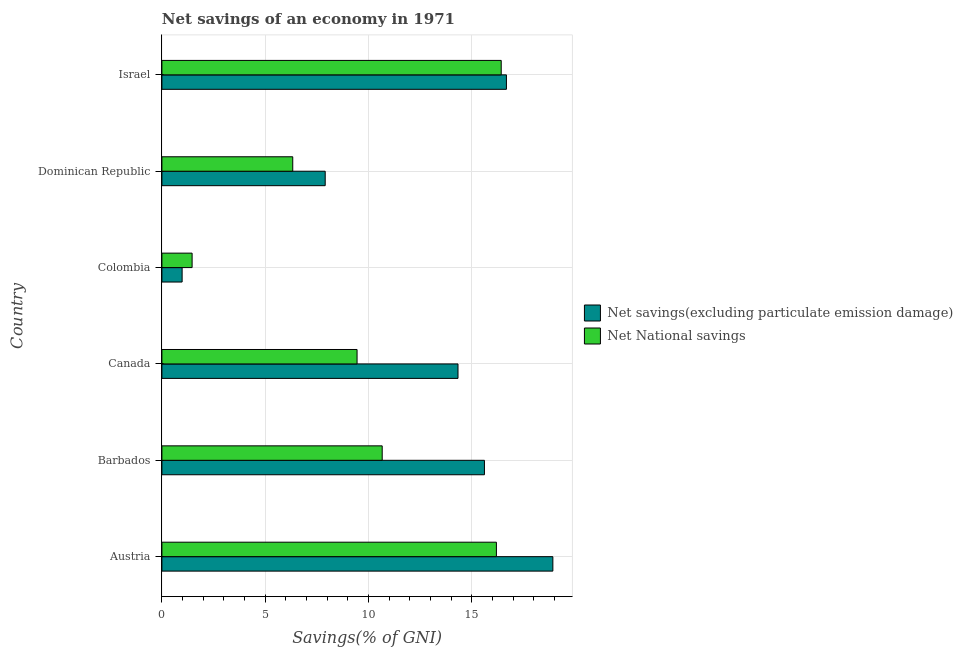Are the number of bars on each tick of the Y-axis equal?
Ensure brevity in your answer.  Yes. What is the label of the 5th group of bars from the top?
Offer a terse response. Barbados. What is the net national savings in Austria?
Offer a terse response. 16.19. Across all countries, what is the maximum net national savings?
Ensure brevity in your answer.  16.42. Across all countries, what is the minimum net national savings?
Provide a succinct answer. 1.46. In which country was the net national savings minimum?
Your answer should be compact. Colombia. What is the total net savings(excluding particulate emission damage) in the graph?
Make the answer very short. 74.42. What is the difference between the net national savings in Austria and that in Israel?
Give a very brief answer. -0.23. What is the difference between the net national savings in Colombia and the net savings(excluding particulate emission damage) in Barbados?
Provide a succinct answer. -14.15. What is the average net savings(excluding particulate emission damage) per country?
Keep it short and to the point. 12.4. What is the difference between the net national savings and net savings(excluding particulate emission damage) in Dominican Republic?
Your answer should be very brief. -1.57. What is the ratio of the net savings(excluding particulate emission damage) in Barbados to that in Dominican Republic?
Ensure brevity in your answer.  1.98. What is the difference between the highest and the second highest net national savings?
Your response must be concise. 0.23. What is the difference between the highest and the lowest net national savings?
Your answer should be very brief. 14.96. In how many countries, is the net national savings greater than the average net national savings taken over all countries?
Keep it short and to the point. 3. Is the sum of the net national savings in Canada and Dominican Republic greater than the maximum net savings(excluding particulate emission damage) across all countries?
Offer a terse response. No. What does the 1st bar from the top in Barbados represents?
Your response must be concise. Net National savings. What does the 2nd bar from the bottom in Canada represents?
Keep it short and to the point. Net National savings. How many bars are there?
Provide a short and direct response. 12. Where does the legend appear in the graph?
Offer a very short reply. Center right. How many legend labels are there?
Your answer should be very brief. 2. What is the title of the graph?
Your answer should be compact. Net savings of an economy in 1971. What is the label or title of the X-axis?
Offer a very short reply. Savings(% of GNI). What is the label or title of the Y-axis?
Make the answer very short. Country. What is the Savings(% of GNI) in Net savings(excluding particulate emission damage) in Austria?
Your response must be concise. 18.92. What is the Savings(% of GNI) of Net National savings in Austria?
Your answer should be compact. 16.19. What is the Savings(% of GNI) in Net savings(excluding particulate emission damage) in Barbados?
Keep it short and to the point. 15.61. What is the Savings(% of GNI) of Net National savings in Barbados?
Offer a terse response. 10.66. What is the Savings(% of GNI) in Net savings(excluding particulate emission damage) in Canada?
Provide a short and direct response. 14.33. What is the Savings(% of GNI) in Net National savings in Canada?
Your answer should be compact. 9.45. What is the Savings(% of GNI) in Net savings(excluding particulate emission damage) in Colombia?
Offer a very short reply. 0.98. What is the Savings(% of GNI) in Net National savings in Colombia?
Ensure brevity in your answer.  1.46. What is the Savings(% of GNI) in Net savings(excluding particulate emission damage) in Dominican Republic?
Keep it short and to the point. 7.9. What is the Savings(% of GNI) of Net National savings in Dominican Republic?
Make the answer very short. 6.33. What is the Savings(% of GNI) in Net savings(excluding particulate emission damage) in Israel?
Your response must be concise. 16.67. What is the Savings(% of GNI) in Net National savings in Israel?
Provide a succinct answer. 16.42. Across all countries, what is the maximum Savings(% of GNI) in Net savings(excluding particulate emission damage)?
Make the answer very short. 18.92. Across all countries, what is the maximum Savings(% of GNI) in Net National savings?
Ensure brevity in your answer.  16.42. Across all countries, what is the minimum Savings(% of GNI) in Net savings(excluding particulate emission damage)?
Provide a succinct answer. 0.98. Across all countries, what is the minimum Savings(% of GNI) of Net National savings?
Offer a terse response. 1.46. What is the total Savings(% of GNI) in Net savings(excluding particulate emission damage) in the graph?
Provide a short and direct response. 74.42. What is the total Savings(% of GNI) in Net National savings in the graph?
Provide a short and direct response. 60.52. What is the difference between the Savings(% of GNI) of Net savings(excluding particulate emission damage) in Austria and that in Barbados?
Ensure brevity in your answer.  3.31. What is the difference between the Savings(% of GNI) in Net National savings in Austria and that in Barbados?
Offer a terse response. 5.53. What is the difference between the Savings(% of GNI) in Net savings(excluding particulate emission damage) in Austria and that in Canada?
Make the answer very short. 4.59. What is the difference between the Savings(% of GNI) of Net National savings in Austria and that in Canada?
Your answer should be very brief. 6.74. What is the difference between the Savings(% of GNI) in Net savings(excluding particulate emission damage) in Austria and that in Colombia?
Ensure brevity in your answer.  17.94. What is the difference between the Savings(% of GNI) of Net National savings in Austria and that in Colombia?
Provide a succinct answer. 14.73. What is the difference between the Savings(% of GNI) of Net savings(excluding particulate emission damage) in Austria and that in Dominican Republic?
Your answer should be compact. 11.02. What is the difference between the Savings(% of GNI) in Net National savings in Austria and that in Dominican Republic?
Your answer should be very brief. 9.86. What is the difference between the Savings(% of GNI) of Net savings(excluding particulate emission damage) in Austria and that in Israel?
Offer a very short reply. 2.25. What is the difference between the Savings(% of GNI) in Net National savings in Austria and that in Israel?
Your answer should be very brief. -0.23. What is the difference between the Savings(% of GNI) of Net savings(excluding particulate emission damage) in Barbados and that in Canada?
Your response must be concise. 1.28. What is the difference between the Savings(% of GNI) in Net National savings in Barbados and that in Canada?
Offer a terse response. 1.22. What is the difference between the Savings(% of GNI) in Net savings(excluding particulate emission damage) in Barbados and that in Colombia?
Provide a short and direct response. 14.63. What is the difference between the Savings(% of GNI) of Net National savings in Barbados and that in Colombia?
Offer a terse response. 9.2. What is the difference between the Savings(% of GNI) of Net savings(excluding particulate emission damage) in Barbados and that in Dominican Republic?
Ensure brevity in your answer.  7.71. What is the difference between the Savings(% of GNI) of Net National savings in Barbados and that in Dominican Republic?
Give a very brief answer. 4.33. What is the difference between the Savings(% of GNI) in Net savings(excluding particulate emission damage) in Barbados and that in Israel?
Provide a short and direct response. -1.06. What is the difference between the Savings(% of GNI) in Net National savings in Barbados and that in Israel?
Make the answer very short. -5.76. What is the difference between the Savings(% of GNI) in Net savings(excluding particulate emission damage) in Canada and that in Colombia?
Provide a succinct answer. 13.35. What is the difference between the Savings(% of GNI) of Net National savings in Canada and that in Colombia?
Your answer should be compact. 7.98. What is the difference between the Savings(% of GNI) of Net savings(excluding particulate emission damage) in Canada and that in Dominican Republic?
Offer a terse response. 6.43. What is the difference between the Savings(% of GNI) of Net National savings in Canada and that in Dominican Republic?
Ensure brevity in your answer.  3.11. What is the difference between the Savings(% of GNI) of Net savings(excluding particulate emission damage) in Canada and that in Israel?
Your response must be concise. -2.34. What is the difference between the Savings(% of GNI) in Net National savings in Canada and that in Israel?
Keep it short and to the point. -6.98. What is the difference between the Savings(% of GNI) in Net savings(excluding particulate emission damage) in Colombia and that in Dominican Republic?
Your answer should be compact. -6.92. What is the difference between the Savings(% of GNI) of Net National savings in Colombia and that in Dominican Republic?
Offer a very short reply. -4.87. What is the difference between the Savings(% of GNI) of Net savings(excluding particulate emission damage) in Colombia and that in Israel?
Your response must be concise. -15.7. What is the difference between the Savings(% of GNI) of Net National savings in Colombia and that in Israel?
Make the answer very short. -14.96. What is the difference between the Savings(% of GNI) in Net savings(excluding particulate emission damage) in Dominican Republic and that in Israel?
Keep it short and to the point. -8.77. What is the difference between the Savings(% of GNI) in Net National savings in Dominican Republic and that in Israel?
Make the answer very short. -10.09. What is the difference between the Savings(% of GNI) in Net savings(excluding particulate emission damage) in Austria and the Savings(% of GNI) in Net National savings in Barbados?
Your answer should be compact. 8.26. What is the difference between the Savings(% of GNI) in Net savings(excluding particulate emission damage) in Austria and the Savings(% of GNI) in Net National savings in Canada?
Offer a very short reply. 9.48. What is the difference between the Savings(% of GNI) in Net savings(excluding particulate emission damage) in Austria and the Savings(% of GNI) in Net National savings in Colombia?
Your answer should be compact. 17.46. What is the difference between the Savings(% of GNI) of Net savings(excluding particulate emission damage) in Austria and the Savings(% of GNI) of Net National savings in Dominican Republic?
Give a very brief answer. 12.59. What is the difference between the Savings(% of GNI) in Net savings(excluding particulate emission damage) in Austria and the Savings(% of GNI) in Net National savings in Israel?
Offer a very short reply. 2.5. What is the difference between the Savings(% of GNI) in Net savings(excluding particulate emission damage) in Barbados and the Savings(% of GNI) in Net National savings in Canada?
Your response must be concise. 6.16. What is the difference between the Savings(% of GNI) of Net savings(excluding particulate emission damage) in Barbados and the Savings(% of GNI) of Net National savings in Colombia?
Offer a terse response. 14.15. What is the difference between the Savings(% of GNI) of Net savings(excluding particulate emission damage) in Barbados and the Savings(% of GNI) of Net National savings in Dominican Republic?
Your answer should be very brief. 9.28. What is the difference between the Savings(% of GNI) in Net savings(excluding particulate emission damage) in Barbados and the Savings(% of GNI) in Net National savings in Israel?
Your answer should be compact. -0.81. What is the difference between the Savings(% of GNI) in Net savings(excluding particulate emission damage) in Canada and the Savings(% of GNI) in Net National savings in Colombia?
Your answer should be compact. 12.87. What is the difference between the Savings(% of GNI) in Net savings(excluding particulate emission damage) in Canada and the Savings(% of GNI) in Net National savings in Dominican Republic?
Provide a succinct answer. 8. What is the difference between the Savings(% of GNI) of Net savings(excluding particulate emission damage) in Canada and the Savings(% of GNI) of Net National savings in Israel?
Your response must be concise. -2.09. What is the difference between the Savings(% of GNI) in Net savings(excluding particulate emission damage) in Colombia and the Savings(% of GNI) in Net National savings in Dominican Republic?
Offer a terse response. -5.35. What is the difference between the Savings(% of GNI) of Net savings(excluding particulate emission damage) in Colombia and the Savings(% of GNI) of Net National savings in Israel?
Your answer should be compact. -15.44. What is the difference between the Savings(% of GNI) in Net savings(excluding particulate emission damage) in Dominican Republic and the Savings(% of GNI) in Net National savings in Israel?
Offer a very short reply. -8.52. What is the average Savings(% of GNI) of Net savings(excluding particulate emission damage) per country?
Offer a very short reply. 12.4. What is the average Savings(% of GNI) of Net National savings per country?
Offer a very short reply. 10.09. What is the difference between the Savings(% of GNI) of Net savings(excluding particulate emission damage) and Savings(% of GNI) of Net National savings in Austria?
Offer a terse response. 2.73. What is the difference between the Savings(% of GNI) of Net savings(excluding particulate emission damage) and Savings(% of GNI) of Net National savings in Barbados?
Offer a very short reply. 4.95. What is the difference between the Savings(% of GNI) in Net savings(excluding particulate emission damage) and Savings(% of GNI) in Net National savings in Canada?
Keep it short and to the point. 4.89. What is the difference between the Savings(% of GNI) in Net savings(excluding particulate emission damage) and Savings(% of GNI) in Net National savings in Colombia?
Offer a very short reply. -0.48. What is the difference between the Savings(% of GNI) in Net savings(excluding particulate emission damage) and Savings(% of GNI) in Net National savings in Dominican Republic?
Your response must be concise. 1.57. What is the difference between the Savings(% of GNI) in Net savings(excluding particulate emission damage) and Savings(% of GNI) in Net National savings in Israel?
Offer a terse response. 0.25. What is the ratio of the Savings(% of GNI) of Net savings(excluding particulate emission damage) in Austria to that in Barbados?
Offer a very short reply. 1.21. What is the ratio of the Savings(% of GNI) of Net National savings in Austria to that in Barbados?
Ensure brevity in your answer.  1.52. What is the ratio of the Savings(% of GNI) in Net savings(excluding particulate emission damage) in Austria to that in Canada?
Make the answer very short. 1.32. What is the ratio of the Savings(% of GNI) of Net National savings in Austria to that in Canada?
Provide a succinct answer. 1.71. What is the ratio of the Savings(% of GNI) of Net savings(excluding particulate emission damage) in Austria to that in Colombia?
Ensure brevity in your answer.  19.32. What is the ratio of the Savings(% of GNI) in Net National savings in Austria to that in Colombia?
Ensure brevity in your answer.  11.07. What is the ratio of the Savings(% of GNI) in Net savings(excluding particulate emission damage) in Austria to that in Dominican Republic?
Your answer should be very brief. 2.39. What is the ratio of the Savings(% of GNI) of Net National savings in Austria to that in Dominican Republic?
Offer a very short reply. 2.56. What is the ratio of the Savings(% of GNI) of Net savings(excluding particulate emission damage) in Austria to that in Israel?
Ensure brevity in your answer.  1.13. What is the ratio of the Savings(% of GNI) in Net National savings in Austria to that in Israel?
Offer a terse response. 0.99. What is the ratio of the Savings(% of GNI) in Net savings(excluding particulate emission damage) in Barbados to that in Canada?
Provide a succinct answer. 1.09. What is the ratio of the Savings(% of GNI) of Net National savings in Barbados to that in Canada?
Offer a terse response. 1.13. What is the ratio of the Savings(% of GNI) in Net savings(excluding particulate emission damage) in Barbados to that in Colombia?
Your answer should be very brief. 15.94. What is the ratio of the Savings(% of GNI) in Net National savings in Barbados to that in Colombia?
Offer a very short reply. 7.29. What is the ratio of the Savings(% of GNI) of Net savings(excluding particulate emission damage) in Barbados to that in Dominican Republic?
Your response must be concise. 1.98. What is the ratio of the Savings(% of GNI) of Net National savings in Barbados to that in Dominican Republic?
Offer a terse response. 1.68. What is the ratio of the Savings(% of GNI) in Net savings(excluding particulate emission damage) in Barbados to that in Israel?
Your answer should be very brief. 0.94. What is the ratio of the Savings(% of GNI) in Net National savings in Barbados to that in Israel?
Your answer should be very brief. 0.65. What is the ratio of the Savings(% of GNI) of Net savings(excluding particulate emission damage) in Canada to that in Colombia?
Your answer should be compact. 14.64. What is the ratio of the Savings(% of GNI) of Net National savings in Canada to that in Colombia?
Provide a succinct answer. 6.46. What is the ratio of the Savings(% of GNI) of Net savings(excluding particulate emission damage) in Canada to that in Dominican Republic?
Provide a short and direct response. 1.81. What is the ratio of the Savings(% of GNI) of Net National savings in Canada to that in Dominican Republic?
Offer a very short reply. 1.49. What is the ratio of the Savings(% of GNI) in Net savings(excluding particulate emission damage) in Canada to that in Israel?
Provide a short and direct response. 0.86. What is the ratio of the Savings(% of GNI) of Net National savings in Canada to that in Israel?
Your answer should be compact. 0.58. What is the ratio of the Savings(% of GNI) in Net savings(excluding particulate emission damage) in Colombia to that in Dominican Republic?
Provide a short and direct response. 0.12. What is the ratio of the Savings(% of GNI) in Net National savings in Colombia to that in Dominican Republic?
Your answer should be very brief. 0.23. What is the ratio of the Savings(% of GNI) in Net savings(excluding particulate emission damage) in Colombia to that in Israel?
Keep it short and to the point. 0.06. What is the ratio of the Savings(% of GNI) in Net National savings in Colombia to that in Israel?
Offer a very short reply. 0.09. What is the ratio of the Savings(% of GNI) in Net savings(excluding particulate emission damage) in Dominican Republic to that in Israel?
Provide a succinct answer. 0.47. What is the ratio of the Savings(% of GNI) in Net National savings in Dominican Republic to that in Israel?
Your answer should be compact. 0.39. What is the difference between the highest and the second highest Savings(% of GNI) in Net savings(excluding particulate emission damage)?
Provide a succinct answer. 2.25. What is the difference between the highest and the second highest Savings(% of GNI) of Net National savings?
Your answer should be compact. 0.23. What is the difference between the highest and the lowest Savings(% of GNI) in Net savings(excluding particulate emission damage)?
Offer a terse response. 17.94. What is the difference between the highest and the lowest Savings(% of GNI) in Net National savings?
Give a very brief answer. 14.96. 